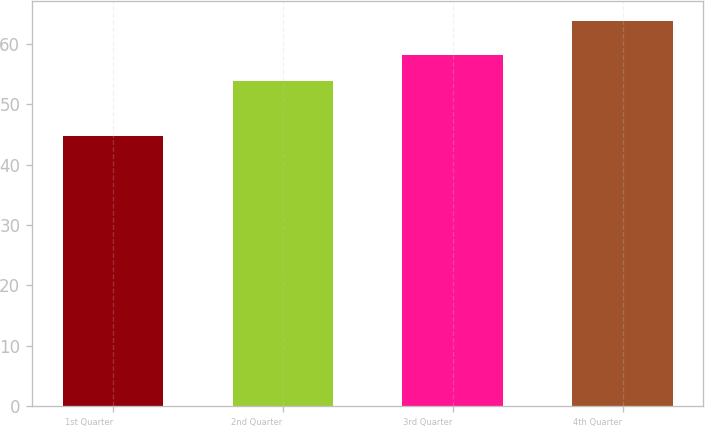<chart> <loc_0><loc_0><loc_500><loc_500><bar_chart><fcel>1st Quarter<fcel>2nd Quarter<fcel>3rd Quarter<fcel>4th Quarter<nl><fcel>44.78<fcel>53.88<fcel>58.14<fcel>63.86<nl></chart> 